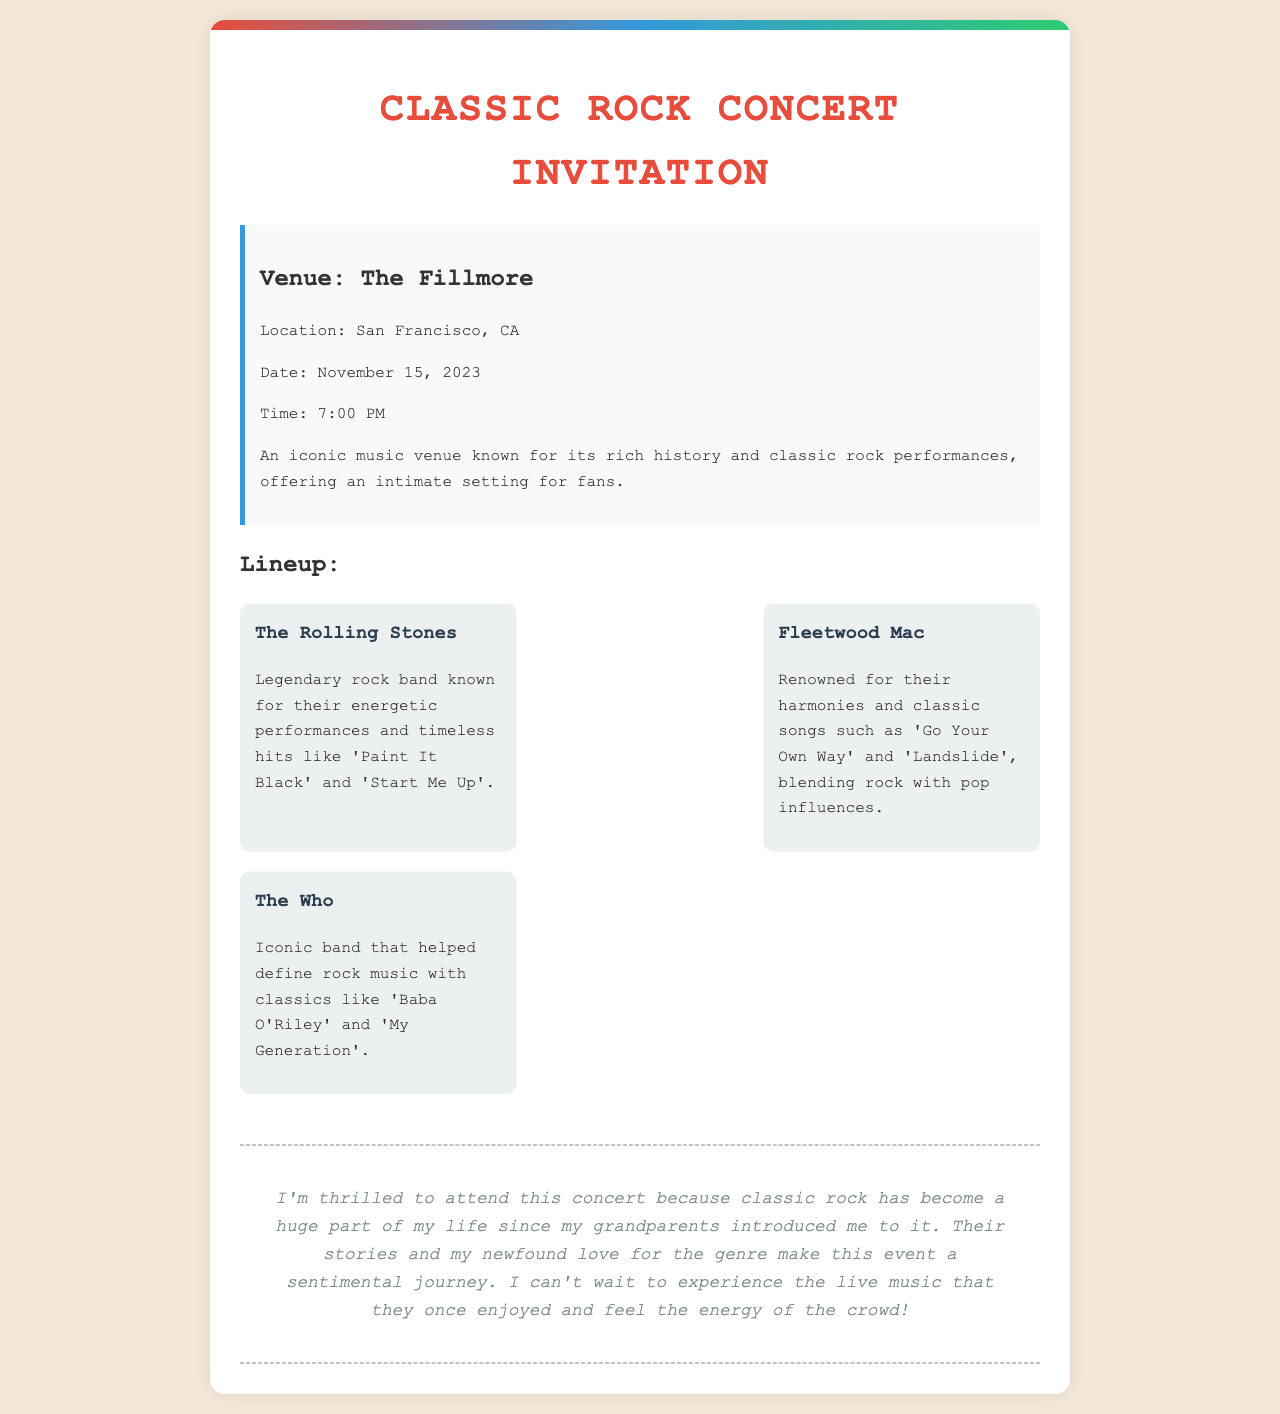What is the venue for the concert? The venue is a key piece of information in the document that is explicitly stated.
Answer: The Fillmore What is the date of the concert? The date provides specific details about when the event will take place.
Answer: November 15, 2023 Who is one of the bands performing? The lineup includes several bands, and naming one is straightforward from the document.
Answer: The Rolling Stones What time does the concert start? This is an important logistical detail that is clearly mentioned in the document.
Answer: 7:00 PM What is one reason the author is excited to attend the concert? This requires understanding the author's emotional connection to the music described in the letter.
Answer: Sentimental journey Which city is the concert being held in? The city is important geographical information found in the venue details.
Answer: San Francisco Name a song by Fleetwood Mac mentioned in the document. The document specifically highlights notable songs associated with the bands in the lineup.
Answer: Go Your Own Way How does the author describe the venue? This requires connecting the information that describes the venue's characteristics in the document.
Answer: Iconic music venue What is a defining characteristic of The Who's music? This involves reasoning about the description of the band and its significance.
Answer: Defined rock music 